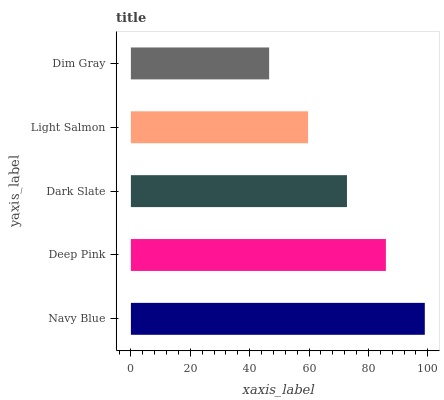Is Dim Gray the minimum?
Answer yes or no. Yes. Is Navy Blue the maximum?
Answer yes or no. Yes. Is Deep Pink the minimum?
Answer yes or no. No. Is Deep Pink the maximum?
Answer yes or no. No. Is Navy Blue greater than Deep Pink?
Answer yes or no. Yes. Is Deep Pink less than Navy Blue?
Answer yes or no. Yes. Is Deep Pink greater than Navy Blue?
Answer yes or no. No. Is Navy Blue less than Deep Pink?
Answer yes or no. No. Is Dark Slate the high median?
Answer yes or no. Yes. Is Dark Slate the low median?
Answer yes or no. Yes. Is Dim Gray the high median?
Answer yes or no. No. Is Light Salmon the low median?
Answer yes or no. No. 